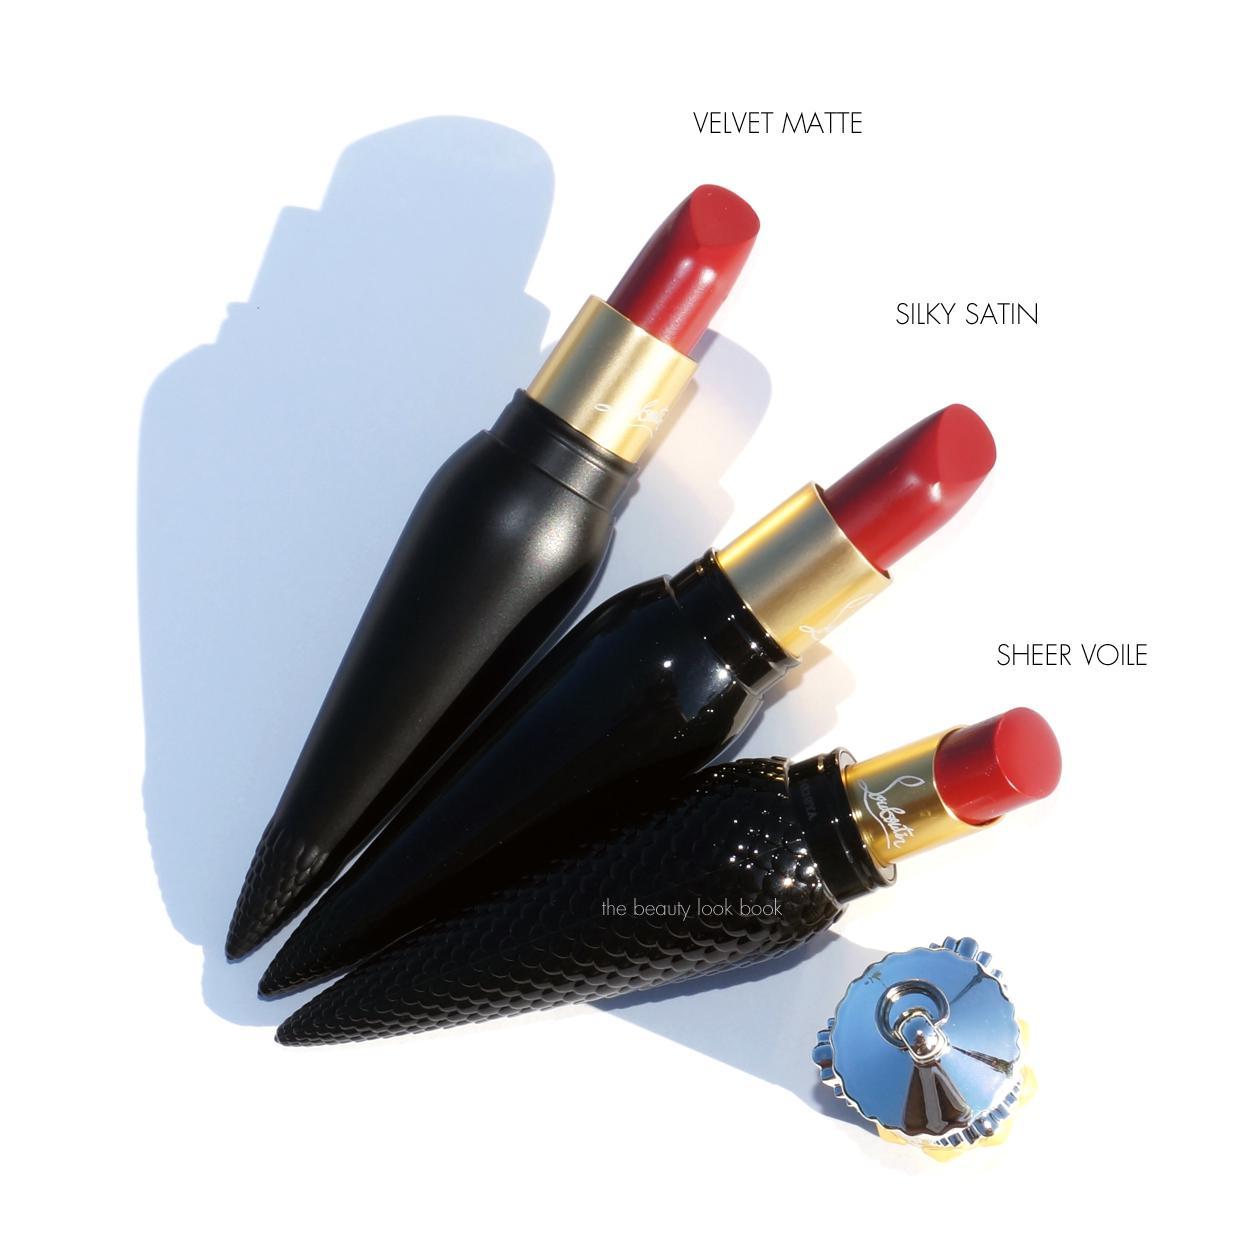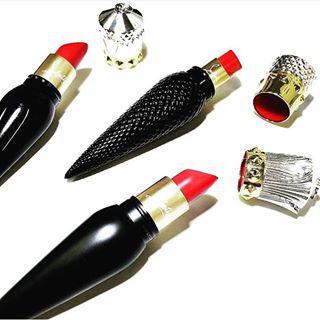The first image is the image on the left, the second image is the image on the right. Analyze the images presented: Is the assertion "Lipstick in a black and gold vial shaped tube is balanced upright on the tip and has a cap that resembles a crown set down next to it." valid? Answer yes or no. No. The first image is the image on the left, the second image is the image on the right. Analyze the images presented: Is the assertion "There are three lipsticks with black cases in at least one image." valid? Answer yes or no. Yes. 